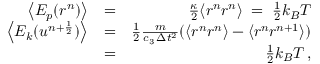Convert formula to latex. <formula><loc_0><loc_0><loc_500><loc_500>\begin{array} { r l r } { \left \langle E _ { p } ( r ^ { n } ) \right \rangle } & { = } & { \frac { \kappa } { 2 } \langle r ^ { n } r ^ { n } \rangle \, = \, \frac { 1 } { 2 } k _ { B } T } \\ { \left \langle E _ { k } ( u ^ { n + \frac { 1 } { 2 } } ) \right \rangle } & { = } & { \frac { 1 } { 2 } \frac { m } { c _ { 3 } \, \Delta { t } ^ { 2 } } ( \langle r ^ { n } r ^ { n } \rangle - \langle r ^ { n } r ^ { n + 1 } \rangle ) } \\ & { = } & { \frac { 1 } { 2 } k _ { B } T \, , } \end{array}</formula> 